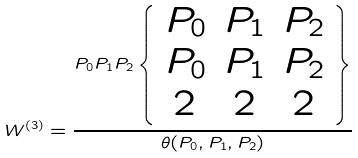<formula> <loc_0><loc_0><loc_500><loc_500>W ^ { ( 3 ) } = \frac { P _ { 0 } P _ { 1 } P _ { 2 } \left \{ \begin{array} { c c c } P _ { 0 } & P _ { 1 } & P _ { 2 } \\ P _ { 0 } & P _ { 1 } & P _ { 2 } \\ 2 & 2 & 2 \end{array} \right \} } { \theta ( P _ { 0 } , P _ { 1 } , P _ { 2 } ) }</formula> 